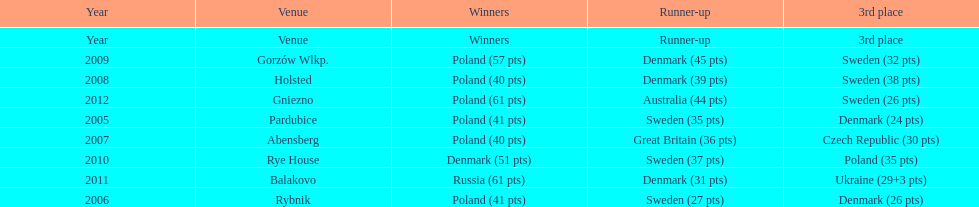What was the last year 3rd place finished with less than 25 points? 2005. 